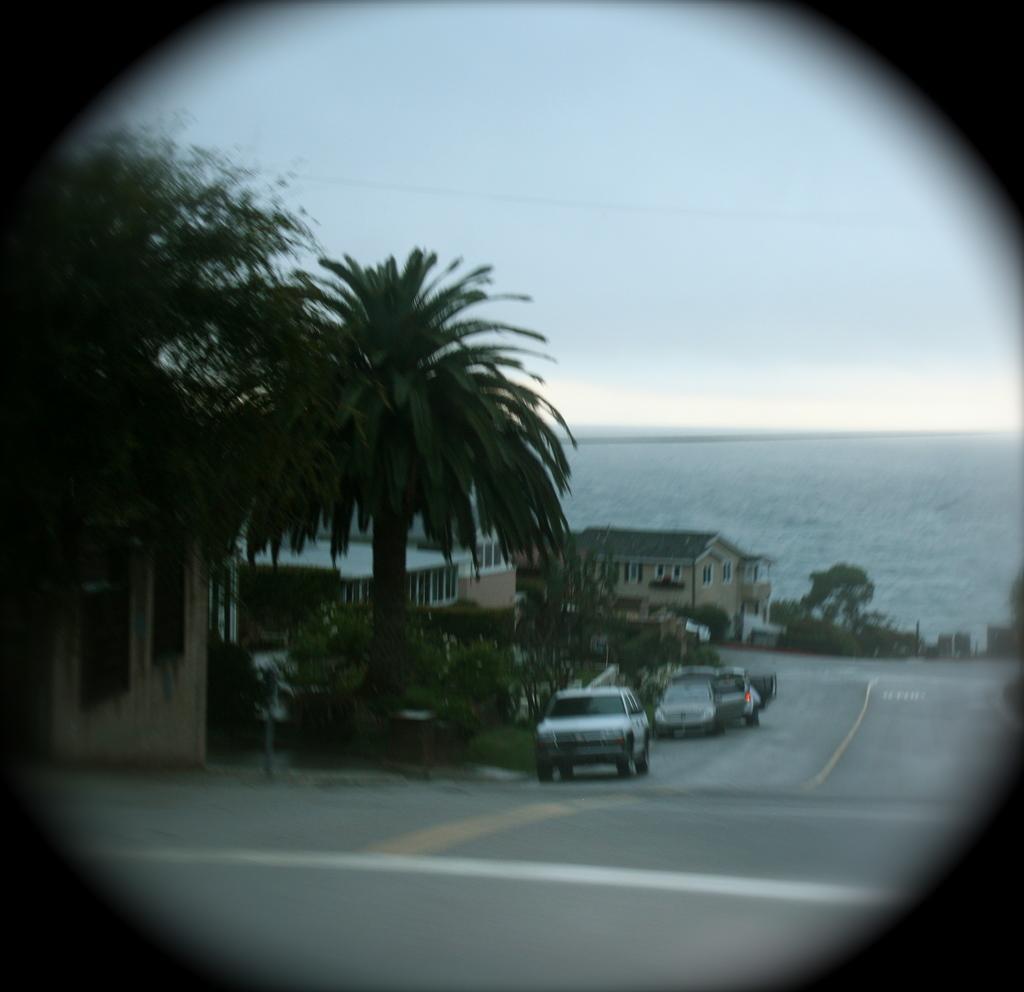Please provide a concise description of this image. There is a road. On the side of the road there are vehicles. Also there are trees. And there are buildings with windows. In the background there is water and sky. 